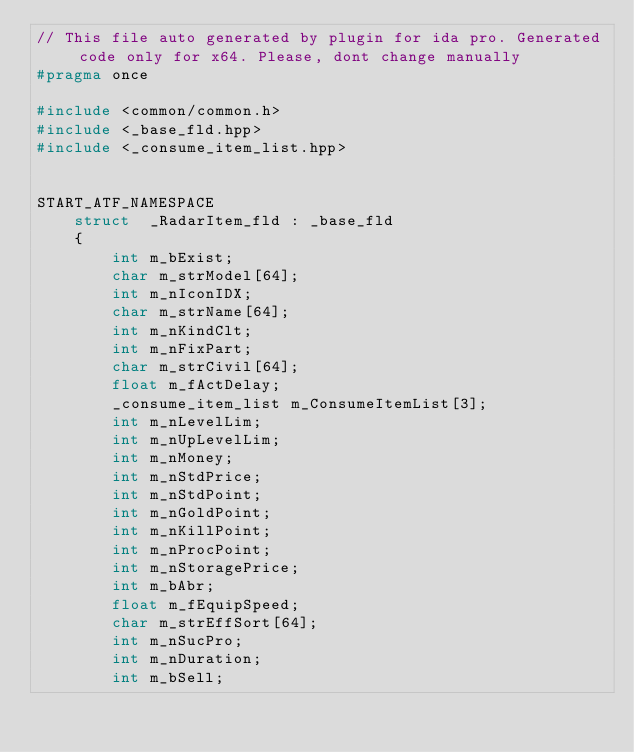Convert code to text. <code><loc_0><loc_0><loc_500><loc_500><_C++_>// This file auto generated by plugin for ida pro. Generated code only for x64. Please, dont change manually
#pragma once

#include <common/common.h>
#include <_base_fld.hpp>
#include <_consume_item_list.hpp>


START_ATF_NAMESPACE
    struct  _RadarItem_fld : _base_fld
    {
        int m_bExist;
        char m_strModel[64];
        int m_nIconIDX;
        char m_strName[64];
        int m_nKindClt;
        int m_nFixPart;
        char m_strCivil[64];
        float m_fActDelay;
        _consume_item_list m_ConsumeItemList[3];
        int m_nLevelLim;
        int m_nUpLevelLim;
        int m_nMoney;
        int m_nStdPrice;
        int m_nStdPoint;
        int m_nGoldPoint;
        int m_nKillPoint;
        int m_nProcPoint;
        int m_nStoragePrice;
        int m_bAbr;
        float m_fEquipSpeed;
        char m_strEffSort[64];
        int m_nSucPro;
        int m_nDuration;
        int m_bSell;</code> 